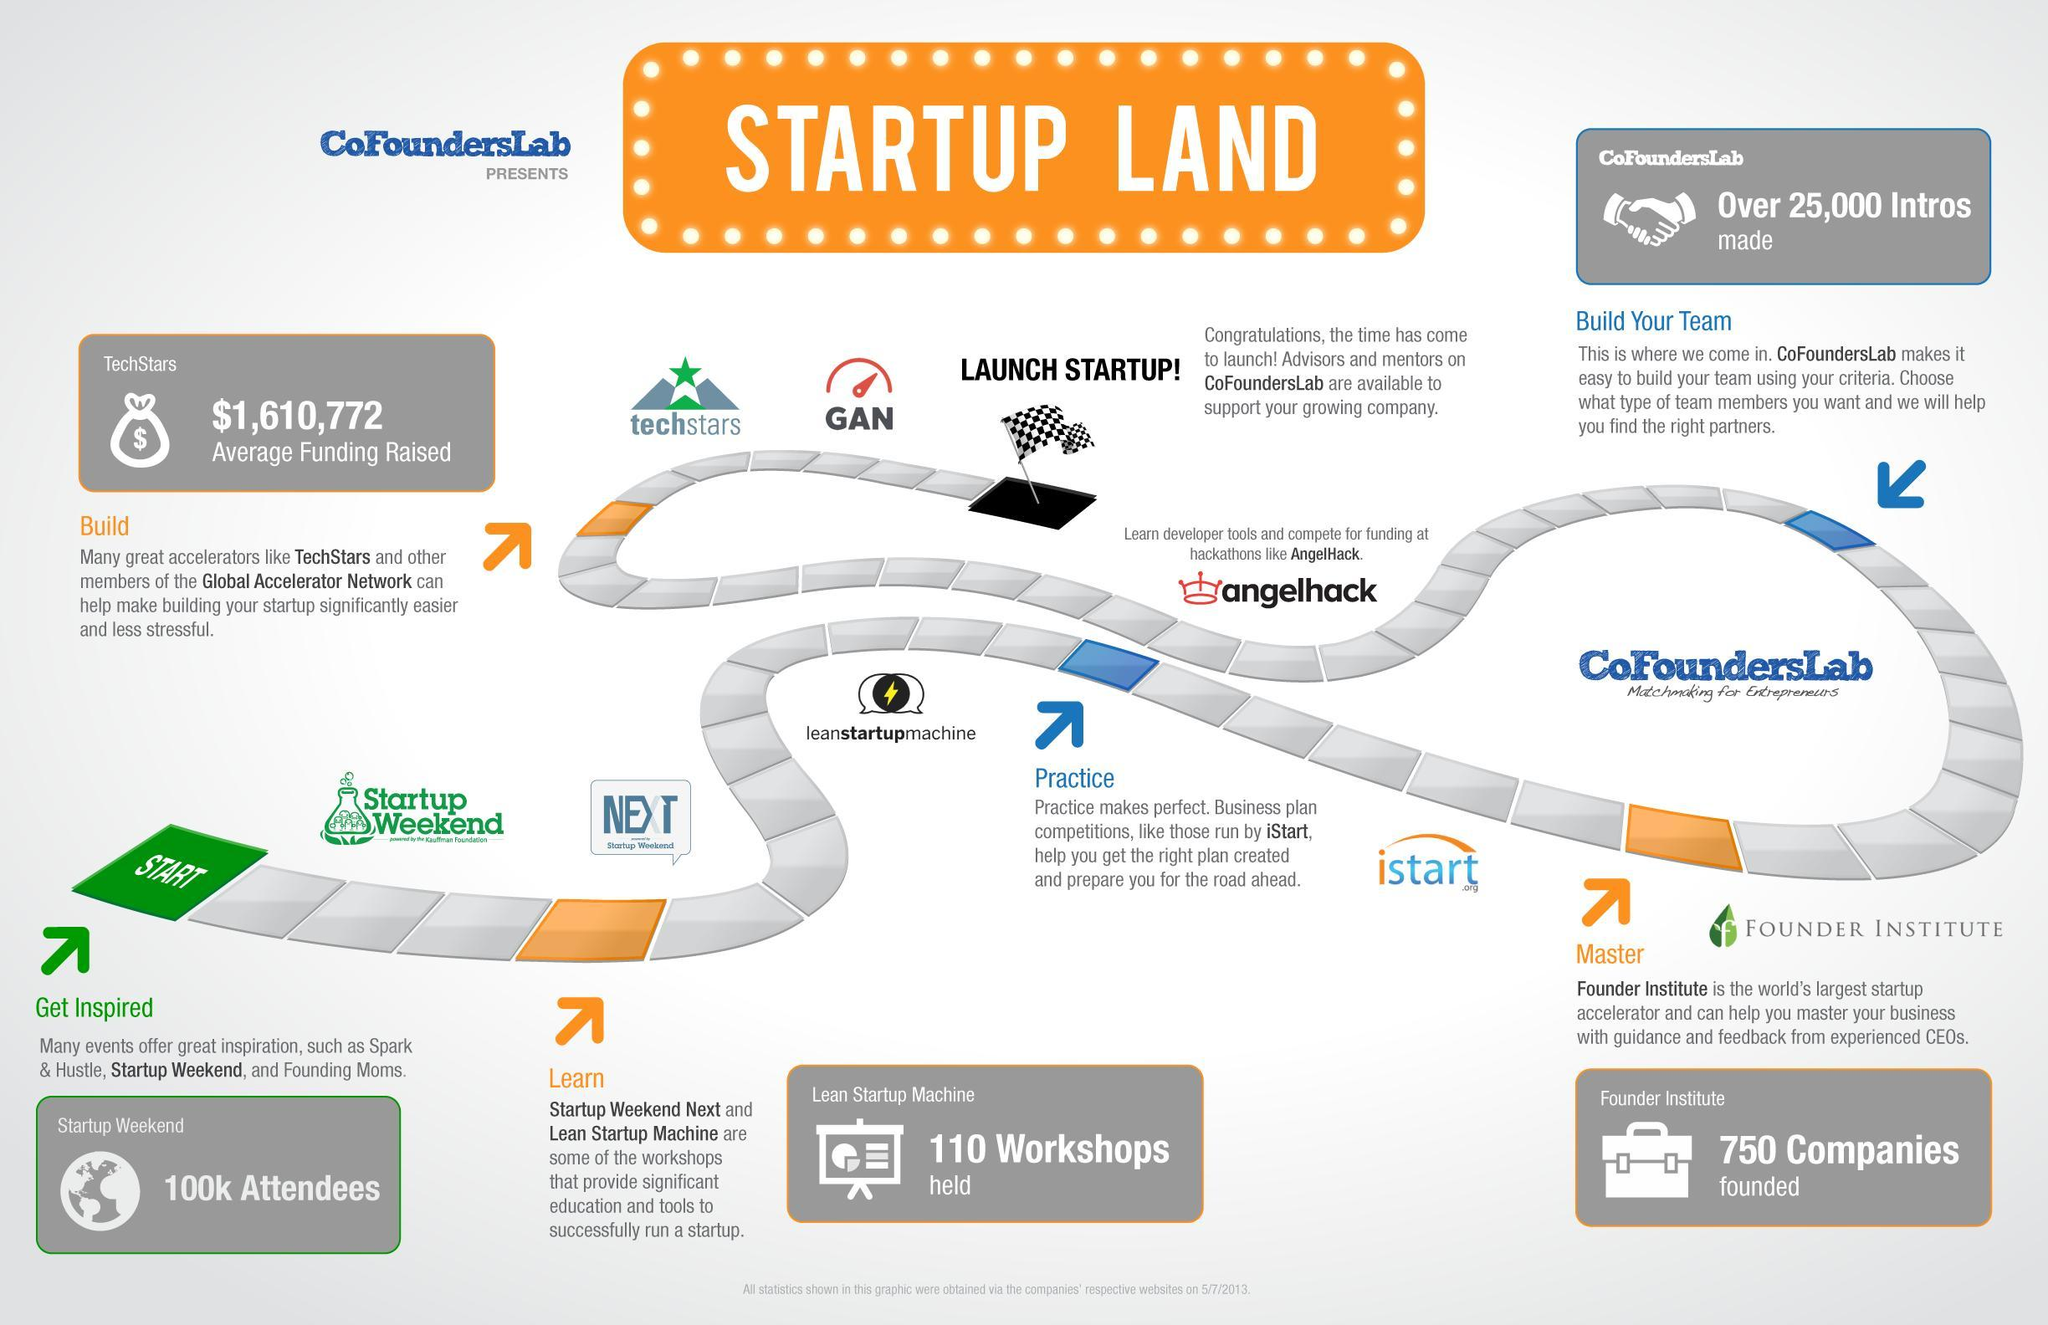How many companies were founded by the Founder Institute as of 5/7/2013?
Answer the question with a short phrase. 750 What is the average fund raised by the Techstars for launching the startups as of 5/7/2013? $1,610,772 Which is the world's largest pre-seed startup accelerator? Founder Institute Which community will help to find the right partners thereby building the startup team? CofoundersLab How many attendees were present in the 'Startup Weekend' event as of 5/7/2013? 100k Attendees How many workshops were organised by the Lean Startup Machine as of 5/7/2013? 110 Workshops 